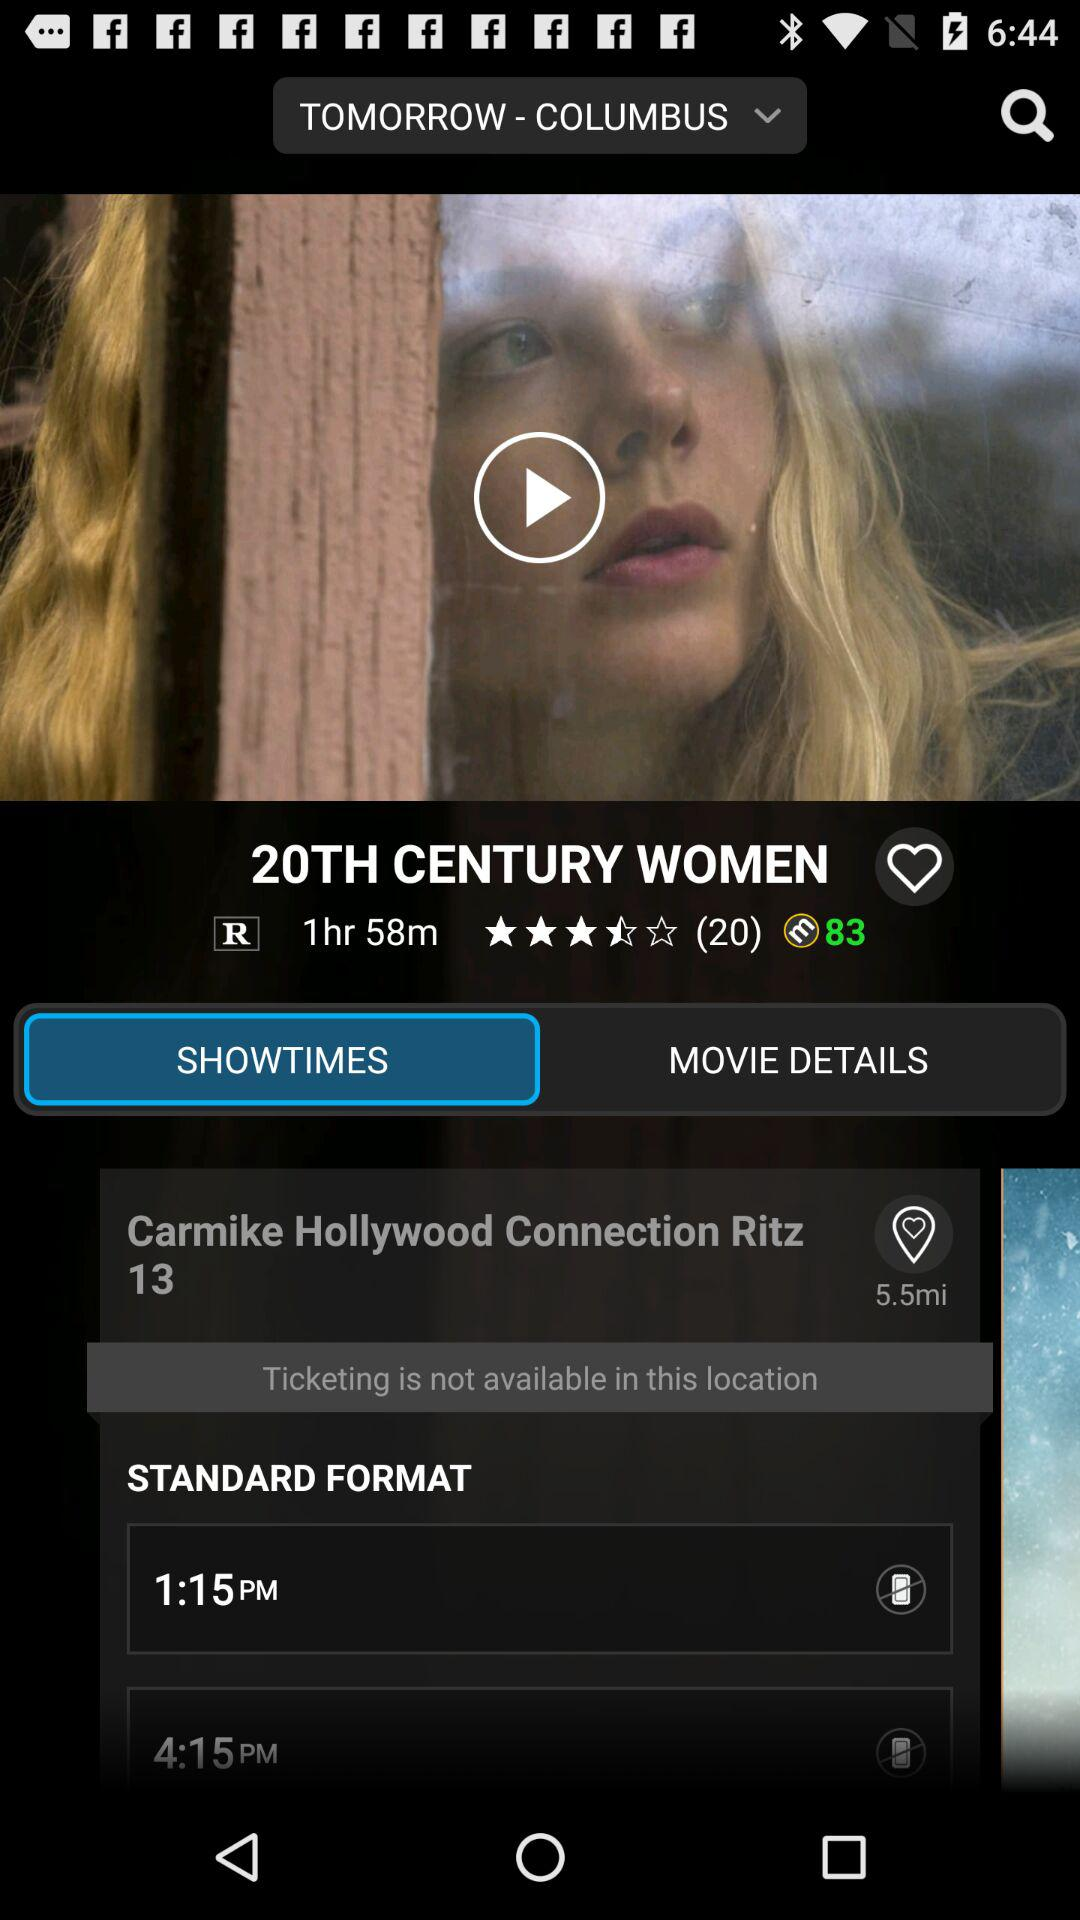What is the duration of the movie? The duration of the movie is 1 hour and 58 minutes. 